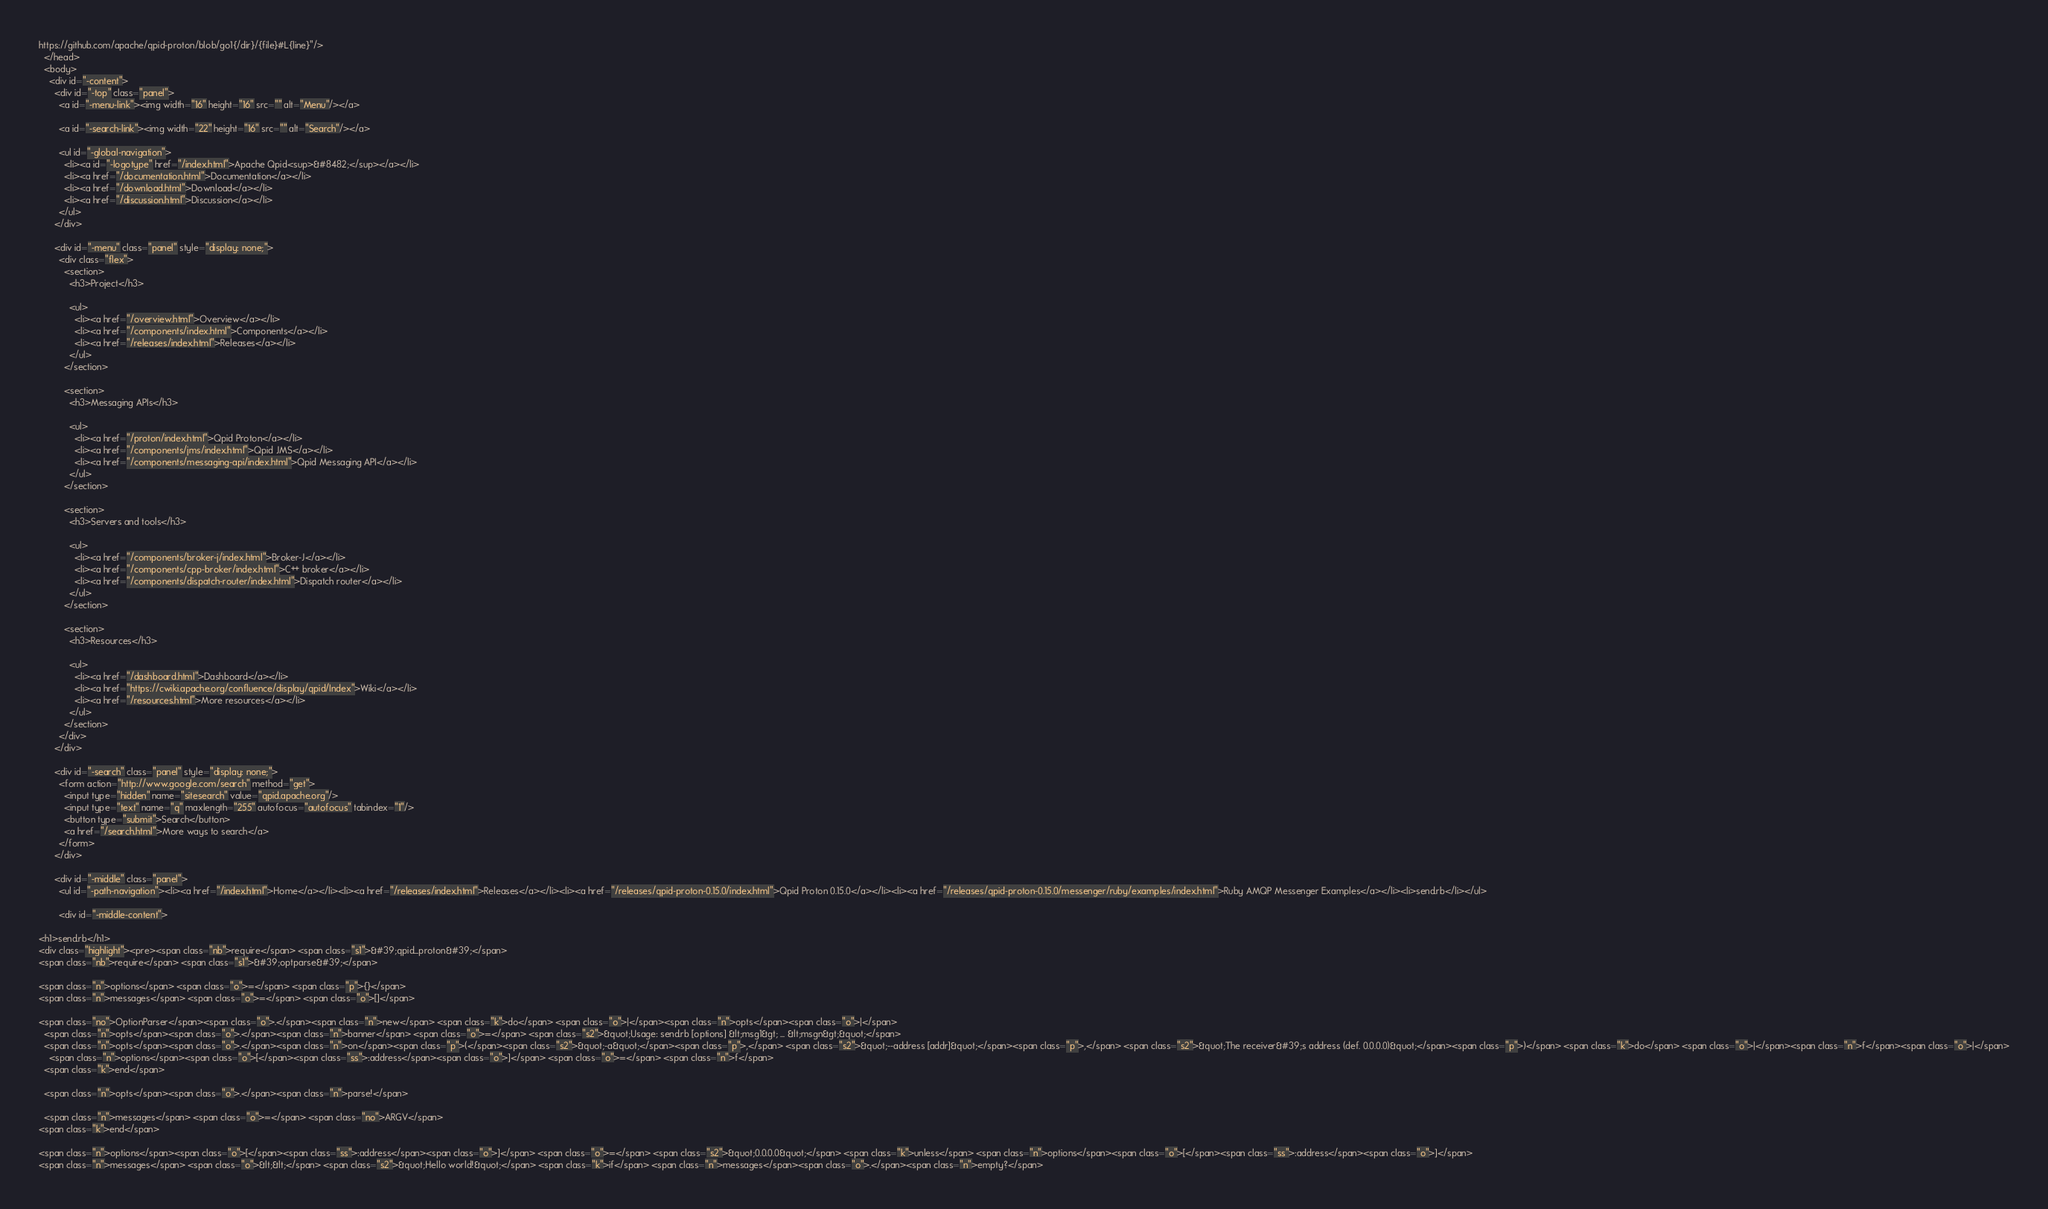Convert code to text. <code><loc_0><loc_0><loc_500><loc_500><_HTML_>https://github.com/apache/qpid-proton/blob/go1{/dir}/{file}#L{line}"/>
  </head>
  <body>
    <div id="-content">
      <div id="-top" class="panel">
        <a id="-menu-link"><img width="16" height="16" src="" alt="Menu"/></a>

        <a id="-search-link"><img width="22" height="16" src="" alt="Search"/></a>

        <ul id="-global-navigation">
          <li><a id="-logotype" href="/index.html">Apache Qpid<sup>&#8482;</sup></a></li>
          <li><a href="/documentation.html">Documentation</a></li>
          <li><a href="/download.html">Download</a></li>
          <li><a href="/discussion.html">Discussion</a></li>
        </ul>
      </div>

      <div id="-menu" class="panel" style="display: none;">
        <div class="flex">
          <section>
            <h3>Project</h3>

            <ul>
              <li><a href="/overview.html">Overview</a></li>
              <li><a href="/components/index.html">Components</a></li>
              <li><a href="/releases/index.html">Releases</a></li>
            </ul>
          </section>

          <section>
            <h3>Messaging APIs</h3>

            <ul>
              <li><a href="/proton/index.html">Qpid Proton</a></li>
              <li><a href="/components/jms/index.html">Qpid JMS</a></li>
              <li><a href="/components/messaging-api/index.html">Qpid Messaging API</a></li>
            </ul>
          </section>

          <section>
            <h3>Servers and tools</h3>

            <ul>
              <li><a href="/components/broker-j/index.html">Broker-J</a></li>
              <li><a href="/components/cpp-broker/index.html">C++ broker</a></li>
              <li><a href="/components/dispatch-router/index.html">Dispatch router</a></li>
            </ul>
          </section>

          <section>
            <h3>Resources</h3>

            <ul>
              <li><a href="/dashboard.html">Dashboard</a></li>
              <li><a href="https://cwiki.apache.org/confluence/display/qpid/Index">Wiki</a></li>
              <li><a href="/resources.html">More resources</a></li>
            </ul>
          </section>
        </div>
      </div>

      <div id="-search" class="panel" style="display: none;">
        <form action="http://www.google.com/search" method="get">
          <input type="hidden" name="sitesearch" value="qpid.apache.org"/>
          <input type="text" name="q" maxlength="255" autofocus="autofocus" tabindex="1"/>
          <button type="submit">Search</button>
          <a href="/search.html">More ways to search</a>
        </form>
      </div>

      <div id="-middle" class="panel">
        <ul id="-path-navigation"><li><a href="/index.html">Home</a></li><li><a href="/releases/index.html">Releases</a></li><li><a href="/releases/qpid-proton-0.15.0/index.html">Qpid Proton 0.15.0</a></li><li><a href="/releases/qpid-proton-0.15.0/messenger/ruby/examples/index.html">Ruby AMQP Messenger Examples</a></li><li>send.rb</li></ul>

        <div id="-middle-content">
          
<h1>send.rb</h1>
<div class="highlight"><pre><span class="nb">require</span> <span class="s1">&#39;qpid_proton&#39;</span>
<span class="nb">require</span> <span class="s1">&#39;optparse&#39;</span>

<span class="n">options</span> <span class="o">=</span> <span class="p">{}</span>
<span class="n">messages</span> <span class="o">=</span> <span class="o">[]</span>

<span class="no">OptionParser</span><span class="o">.</span><span class="n">new</span> <span class="k">do</span> <span class="o">|</span><span class="n">opts</span><span class="o">|</span>
  <span class="n">opts</span><span class="o">.</span><span class="n">banner</span> <span class="o">=</span> <span class="s2">&quot;Usage: send.rb [options] &lt;msg1&gt; ... &lt;msgn&gt;&quot;</span>
  <span class="n">opts</span><span class="o">.</span><span class="n">on</span><span class="p">(</span><span class="s2">&quot;-a&quot;</span><span class="p">,</span> <span class="s2">&quot;--address [addr]&quot;</span><span class="p">,</span> <span class="s2">&quot;The receiver&#39;s address (def. 0.0.0.0)&quot;</span><span class="p">)</span> <span class="k">do</span> <span class="o">|</span><span class="n">f</span><span class="o">|</span>
    <span class="n">options</span><span class="o">[</span><span class="ss">:address</span><span class="o">]</span> <span class="o">=</span> <span class="n">f</span>
  <span class="k">end</span>

  <span class="n">opts</span><span class="o">.</span><span class="n">parse!</span>

  <span class="n">messages</span> <span class="o">=</span> <span class="no">ARGV</span>
<span class="k">end</span>

<span class="n">options</span><span class="o">[</span><span class="ss">:address</span><span class="o">]</span> <span class="o">=</span> <span class="s2">&quot;0.0.0.0&quot;</span> <span class="k">unless</span> <span class="n">options</span><span class="o">[</span><span class="ss">:address</span><span class="o">]</span>
<span class="n">messages</span> <span class="o">&lt;&lt;</span> <span class="s2">&quot;Hello world!&quot;</span> <span class="k">if</span> <span class="n">messages</span><span class="o">.</span><span class="n">empty?</span>
</code> 